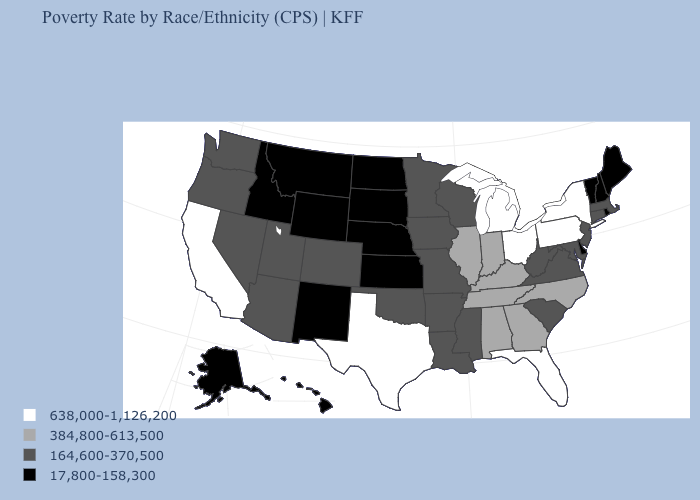Name the states that have a value in the range 164,600-370,500?
Answer briefly. Arizona, Arkansas, Colorado, Connecticut, Iowa, Louisiana, Maryland, Massachusetts, Minnesota, Mississippi, Missouri, Nevada, New Jersey, Oklahoma, Oregon, South Carolina, Utah, Virginia, Washington, West Virginia, Wisconsin. What is the lowest value in the USA?
Write a very short answer. 17,800-158,300. Name the states that have a value in the range 17,800-158,300?
Short answer required. Alaska, Delaware, Hawaii, Idaho, Kansas, Maine, Montana, Nebraska, New Hampshire, New Mexico, North Dakota, Rhode Island, South Dakota, Vermont, Wyoming. Which states have the lowest value in the USA?
Short answer required. Alaska, Delaware, Hawaii, Idaho, Kansas, Maine, Montana, Nebraska, New Hampshire, New Mexico, North Dakota, Rhode Island, South Dakota, Vermont, Wyoming. What is the value of Montana?
Give a very brief answer. 17,800-158,300. How many symbols are there in the legend?
Write a very short answer. 4. What is the lowest value in the USA?
Concise answer only. 17,800-158,300. Name the states that have a value in the range 638,000-1,126,200?
Quick response, please. California, Florida, Michigan, New York, Ohio, Pennsylvania, Texas. What is the lowest value in states that border Kentucky?
Answer briefly. 164,600-370,500. What is the lowest value in the MidWest?
Answer briefly. 17,800-158,300. What is the lowest value in the MidWest?
Write a very short answer. 17,800-158,300. Name the states that have a value in the range 638,000-1,126,200?
Concise answer only. California, Florida, Michigan, New York, Ohio, Pennsylvania, Texas. Name the states that have a value in the range 384,800-613,500?
Short answer required. Alabama, Georgia, Illinois, Indiana, Kentucky, North Carolina, Tennessee. Name the states that have a value in the range 164,600-370,500?
Keep it brief. Arizona, Arkansas, Colorado, Connecticut, Iowa, Louisiana, Maryland, Massachusetts, Minnesota, Mississippi, Missouri, Nevada, New Jersey, Oklahoma, Oregon, South Carolina, Utah, Virginia, Washington, West Virginia, Wisconsin. What is the lowest value in the USA?
Write a very short answer. 17,800-158,300. 